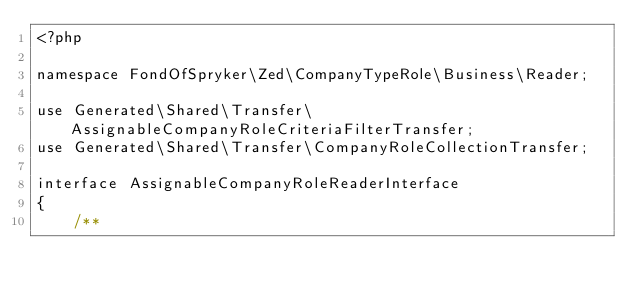<code> <loc_0><loc_0><loc_500><loc_500><_PHP_><?php

namespace FondOfSpryker\Zed\CompanyTypeRole\Business\Reader;

use Generated\Shared\Transfer\AssignableCompanyRoleCriteriaFilterTransfer;
use Generated\Shared\Transfer\CompanyRoleCollectionTransfer;

interface AssignableCompanyRoleReaderInterface
{
    /**</code> 